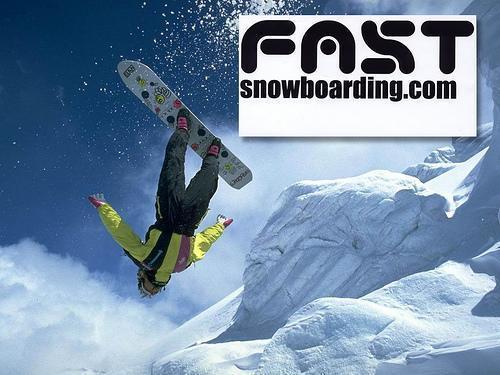How many snowboards are there?
Give a very brief answer. 1. 